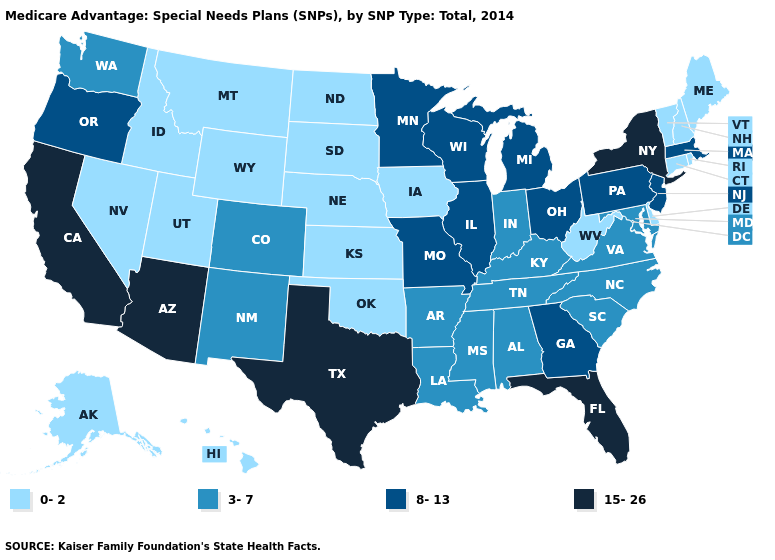How many symbols are there in the legend?
Give a very brief answer. 4. Does Massachusetts have the lowest value in the USA?
Keep it brief. No. What is the value of Wisconsin?
Give a very brief answer. 8-13. Does Ohio have the highest value in the MidWest?
Short answer required. Yes. What is the value of Maine?
Write a very short answer. 0-2. Name the states that have a value in the range 15-26?
Quick response, please. Arizona, California, Florida, New York, Texas. Which states have the highest value in the USA?
Be succinct. Arizona, California, Florida, New York, Texas. Is the legend a continuous bar?
Keep it brief. No. What is the value of Kentucky?
Give a very brief answer. 3-7. Among the states that border Iowa , which have the highest value?
Quick response, please. Illinois, Minnesota, Missouri, Wisconsin. Which states hav the highest value in the South?
Give a very brief answer. Florida, Texas. Does Missouri have the same value as Texas?
Keep it brief. No. Name the states that have a value in the range 8-13?
Give a very brief answer. Georgia, Illinois, Massachusetts, Michigan, Minnesota, Missouri, New Jersey, Ohio, Oregon, Pennsylvania, Wisconsin. What is the value of Michigan?
Give a very brief answer. 8-13. What is the value of Vermont?
Keep it brief. 0-2. 